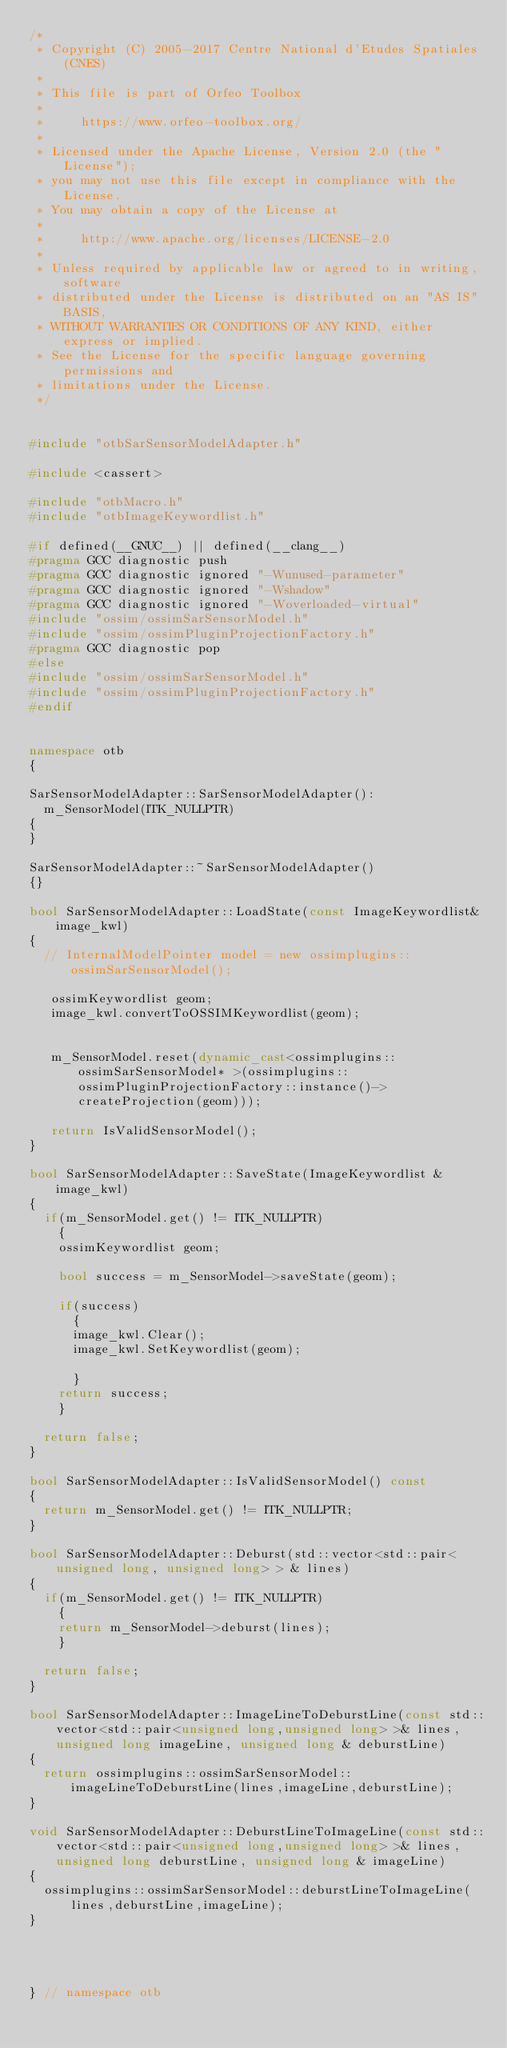<code> <loc_0><loc_0><loc_500><loc_500><_C++_>/*
 * Copyright (C) 2005-2017 Centre National d'Etudes Spatiales (CNES)
 *
 * This file is part of Orfeo Toolbox
 *
 *     https://www.orfeo-toolbox.org/
 *
 * Licensed under the Apache License, Version 2.0 (the "License");
 * you may not use this file except in compliance with the License.
 * You may obtain a copy of the License at
 *
 *     http://www.apache.org/licenses/LICENSE-2.0
 *
 * Unless required by applicable law or agreed to in writing, software
 * distributed under the License is distributed on an "AS IS" BASIS,
 * WITHOUT WARRANTIES OR CONDITIONS OF ANY KIND, either express or implied.
 * See the License for the specific language governing permissions and
 * limitations under the License.
 */


#include "otbSarSensorModelAdapter.h"

#include <cassert>

#include "otbMacro.h"
#include "otbImageKeywordlist.h"

#if defined(__GNUC__) || defined(__clang__)
#pragma GCC diagnostic push
#pragma GCC diagnostic ignored "-Wunused-parameter"
#pragma GCC diagnostic ignored "-Wshadow"
#pragma GCC diagnostic ignored "-Woverloaded-virtual"
#include "ossim/ossimSarSensorModel.h"
#include "ossim/ossimPluginProjectionFactory.h"
#pragma GCC diagnostic pop
#else
#include "ossim/ossimSarSensorModel.h"
#include "ossim/ossimPluginProjectionFactory.h"
#endif


namespace otb
{

SarSensorModelAdapter::SarSensorModelAdapter():
  m_SensorModel(ITK_NULLPTR)
{
}

SarSensorModelAdapter::~SarSensorModelAdapter()
{}

bool SarSensorModelAdapter::LoadState(const ImageKeywordlist& image_kwl)
{
  // InternalModelPointer model = new ossimplugins::ossimSarSensorModel();

   ossimKeywordlist geom;
   image_kwl.convertToOSSIMKeywordlist(geom);

   
   m_SensorModel.reset(dynamic_cast<ossimplugins::ossimSarSensorModel* >(ossimplugins::ossimPluginProjectionFactory::instance()->createProjection(geom)));

   return IsValidSensorModel();
}

bool SarSensorModelAdapter::SaveState(ImageKeywordlist & image_kwl)
{
  if(m_SensorModel.get() != ITK_NULLPTR)
    {
    ossimKeywordlist geom;

    bool success = m_SensorModel->saveState(geom);

    if(success)
      {
      image_kwl.Clear();
      image_kwl.SetKeywordlist(geom);
      
      }
    return success;
    }

  return false;  
}

bool SarSensorModelAdapter::IsValidSensorModel() const
{
  return m_SensorModel.get() != ITK_NULLPTR;
}

bool SarSensorModelAdapter::Deburst(std::vector<std::pair<unsigned long, unsigned long> > & lines)
{
  if(m_SensorModel.get() != ITK_NULLPTR)
    {
    return m_SensorModel->deburst(lines);
    }
  
  return false;
}

bool SarSensorModelAdapter::ImageLineToDeburstLine(const std::vector<std::pair<unsigned long,unsigned long> >& lines, unsigned long imageLine, unsigned long & deburstLine)
{
  return ossimplugins::ossimSarSensorModel::imageLineToDeburstLine(lines,imageLine,deburstLine);
}

void SarSensorModelAdapter::DeburstLineToImageLine(const std::vector<std::pair<unsigned long,unsigned long> >& lines, unsigned long deburstLine, unsigned long & imageLine)
{
  ossimplugins::ossimSarSensorModel::deburstLineToImageLine(lines,deburstLine,imageLine);
}




} // namespace otb
</code> 